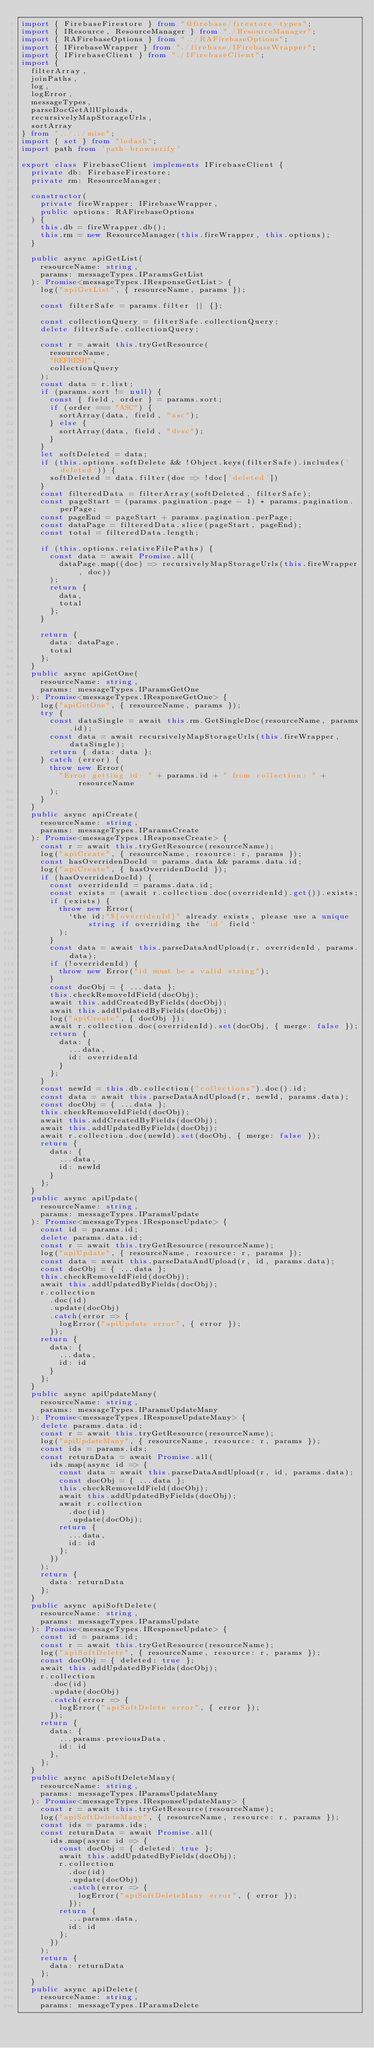Convert code to text. <code><loc_0><loc_0><loc_500><loc_500><_TypeScript_>import { FirebaseFirestore } from "@firebase/firestore-types";
import { IResource, ResourceManager } from "./ResourceManager";
import { RAFirebaseOptions } from "../RAFirebaseOptions";
import { IFirebaseWrapper } from "./firebase/IFirebaseWrapper";
import { IFirebaseClient } from "./IFirebaseClient";
import {
  filterArray,
  joinPaths,
  log,
  logError,
  messageTypes,
  parseDocGetAllUploads,
  recursivelyMapStorageUrls,
  sortArray
} from "../../misc";
import { set } from "lodash";
import path from 'path-browserify'

export class FirebaseClient implements IFirebaseClient {
  private db: FirebaseFirestore;
  private rm: ResourceManager;

  constructor(
    private fireWrapper: IFirebaseWrapper,
    public options: RAFirebaseOptions
  ) {
    this.db = fireWrapper.db();
    this.rm = new ResourceManager(this.fireWrapper, this.options);
  }

  public async apiGetList(
    resourceName: string,
    params: messageTypes.IParamsGetList
  ): Promise<messageTypes.IResponseGetList> {
    log("apiGetList", { resourceName, params });

    const filterSafe = params.filter || {};

    const collectionQuery = filterSafe.collectionQuery;
    delete filterSafe.collectionQuery;

    const r = await this.tryGetResource(
      resourceName,
      "REFRESH",
      collectionQuery
    );
    const data = r.list;
    if (params.sort != null) {
      const { field, order } = params.sort;
      if (order === "ASC") {
        sortArray(data, field, "asc");
      } else {
        sortArray(data, field, "desc");
      }
    }
    let softDeleted = data;
    if (this.options.softDelete && !Object.keys(filterSafe).includes('deleted')) {
      softDeleted = data.filter(doc => !doc['deleted'])
    }
    const filteredData = filterArray(softDeleted, filterSafe);
    const pageStart = (params.pagination.page - 1) * params.pagination.perPage;
    const pageEnd = pageStart + params.pagination.perPage;
    const dataPage = filteredData.slice(pageStart, pageEnd);
    const total = filteredData.length;

    if (this.options.relativeFilePaths) {
      const data = await Promise.all(
        dataPage.map((doc) => recursivelyMapStorageUrls(this.fireWrapper, doc))
      );
      return {
        data,
        total
      };
    }

    return {
      data: dataPage,
      total
    };
  }
  public async apiGetOne(
    resourceName: string,
    params: messageTypes.IParamsGetOne
  ): Promise<messageTypes.IResponseGetOne> {
    log("apiGetOne", { resourceName, params });
    try {
      const dataSingle = await this.rm.GetSingleDoc(resourceName, params.id);
      const data = await recursivelyMapStorageUrls(this.fireWrapper, dataSingle);
      return { data: data };
    } catch (error) {
      throw new Error(
        "Error getting id: " + params.id + " from collection: " + resourceName
      );
    }
  }
  public async apiCreate(
    resourceName: string,
    params: messageTypes.IParamsCreate
  ): Promise<messageTypes.IResponseCreate> {
    const r = await this.tryGetResource(resourceName);
    log("apiCreate", { resourceName, resource: r, params });
    const hasOverridenDocId = params.data && params.data.id;
    log("apiCreate", { hasOverridenDocId });
    if (hasOverridenDocId) {
      const overridenId = params.data.id;
      const exists = (await r.collection.doc(overridenId).get()).exists;
      if (exists) {
        throw new Error(
          `the id:"${overridenId}" already exists, please use a unique string if overriding the 'id' field`
        );
      }
      const data = await this.parseDataAndUpload(r, overridenId, params.data);
      if (!overridenId) {
        throw new Error("id must be a valid string");
      }
      const docObj = { ...data };
      this.checkRemoveIdField(docObj);
      await this.addCreatedByFields(docObj);
      await this.addUpdatedByFields(docObj);
      log("apiCreate", { docObj });
      await r.collection.doc(overridenId).set(docObj, { merge: false });
      return {
        data: {
          ...data,
          id: overridenId
        }
      };
    }
    const newId = this.db.collection("collections").doc().id;
    const data = await this.parseDataAndUpload(r, newId, params.data);
    const docObj = { ...data };
    this.checkRemoveIdField(docObj);
    await this.addCreatedByFields(docObj);
    await this.addUpdatedByFields(docObj);
    await r.collection.doc(newId).set(docObj, { merge: false });
    return {
      data: {
        ...data,
        id: newId
      }
    };
  }
  public async apiUpdate(
    resourceName: string,
    params: messageTypes.IParamsUpdate
  ): Promise<messageTypes.IResponseUpdate> {
    const id = params.id;
    delete params.data.id;
    const r = await this.tryGetResource(resourceName);
    log("apiUpdate", { resourceName, resource: r, params });
    const data = await this.parseDataAndUpload(r, id, params.data);
    const docObj = { ...data };
    this.checkRemoveIdField(docObj);
    await this.addUpdatedByFields(docObj);
    r.collection
      .doc(id)
      .update(docObj)
      .catch(error => {
        logError("apiUpdate error", { error });
      });
    return {
      data: {
        ...data,
        id: id
      }
    };
  }
  public async apiUpdateMany(
    resourceName: string,
    params: messageTypes.IParamsUpdateMany
  ): Promise<messageTypes.IResponseUpdateMany> {
    delete params.data.id;
    const r = await this.tryGetResource(resourceName);
    log("apiUpdateMany", { resourceName, resource: r, params });
    const ids = params.ids;
    const returnData = await Promise.all(
      ids.map(async id => {
        const data = await this.parseDataAndUpload(r, id, params.data);
        const docObj = { ...data };
        this.checkRemoveIdField(docObj);
        await this.addUpdatedByFields(docObj);
        await r.collection
          .doc(id)
          .update(docObj);
        return {
          ...data,
          id: id
        };
      })
    );
    return {
      data: returnData
    };
  }
  public async apiSoftDelete(
    resourceName: string,
    params: messageTypes.IParamsUpdate
  ): Promise<messageTypes.IResponseUpdate> {
    const id = params.id;
    const r = await this.tryGetResource(resourceName);
    log("apiSoftDelete", { resourceName, resource: r, params });
    const docObj = { deleted: true };
    await this.addUpdatedByFields(docObj);
    r.collection
      .doc(id)
      .update(docObj)
      .catch(error => {
        logError("apiSoftDelete error", { error });
      });
    return {
      data: {
        ...params.previousData,
        id: id
      },
    };
  }
  public async apiSoftDeleteMany(
    resourceName: string,
    params: messageTypes.IParamsUpdateMany
  ): Promise<messageTypes.IResponseUpdateMany> {
    const r = await this.tryGetResource(resourceName);
    log("apiSoftDeleteMany", { resourceName, resource: r, params });
    const ids = params.ids;
    const returnData = await Promise.all(
      ids.map(async id => {
        const docObj = { deleted: true };
        await this.addUpdatedByFields(docObj);
        r.collection
          .doc(id)
          .update(docObj)
          .catch(error => {
            logError("apiSoftDeleteMany error", { error });
          });
        return {
          ...params.data,
          id: id
        };
      })
    );
    return {
      data: returnData
    };
  }
  public async apiDelete(
    resourceName: string,
    params: messageTypes.IParamsDelete</code> 